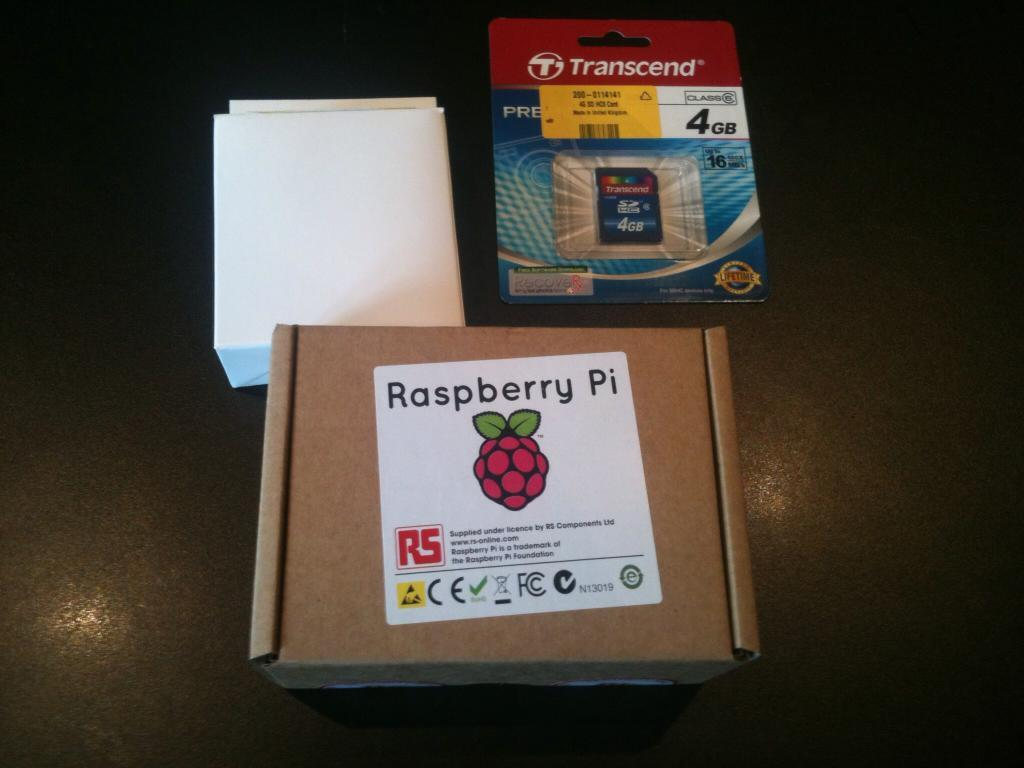What piece of furniture is present in the image? There is a table in the image. What objects are placed on the table? There are two boxes and one packet on the table. What type of grape is visible on the table in the image? There is no grape present on the table in the image. 